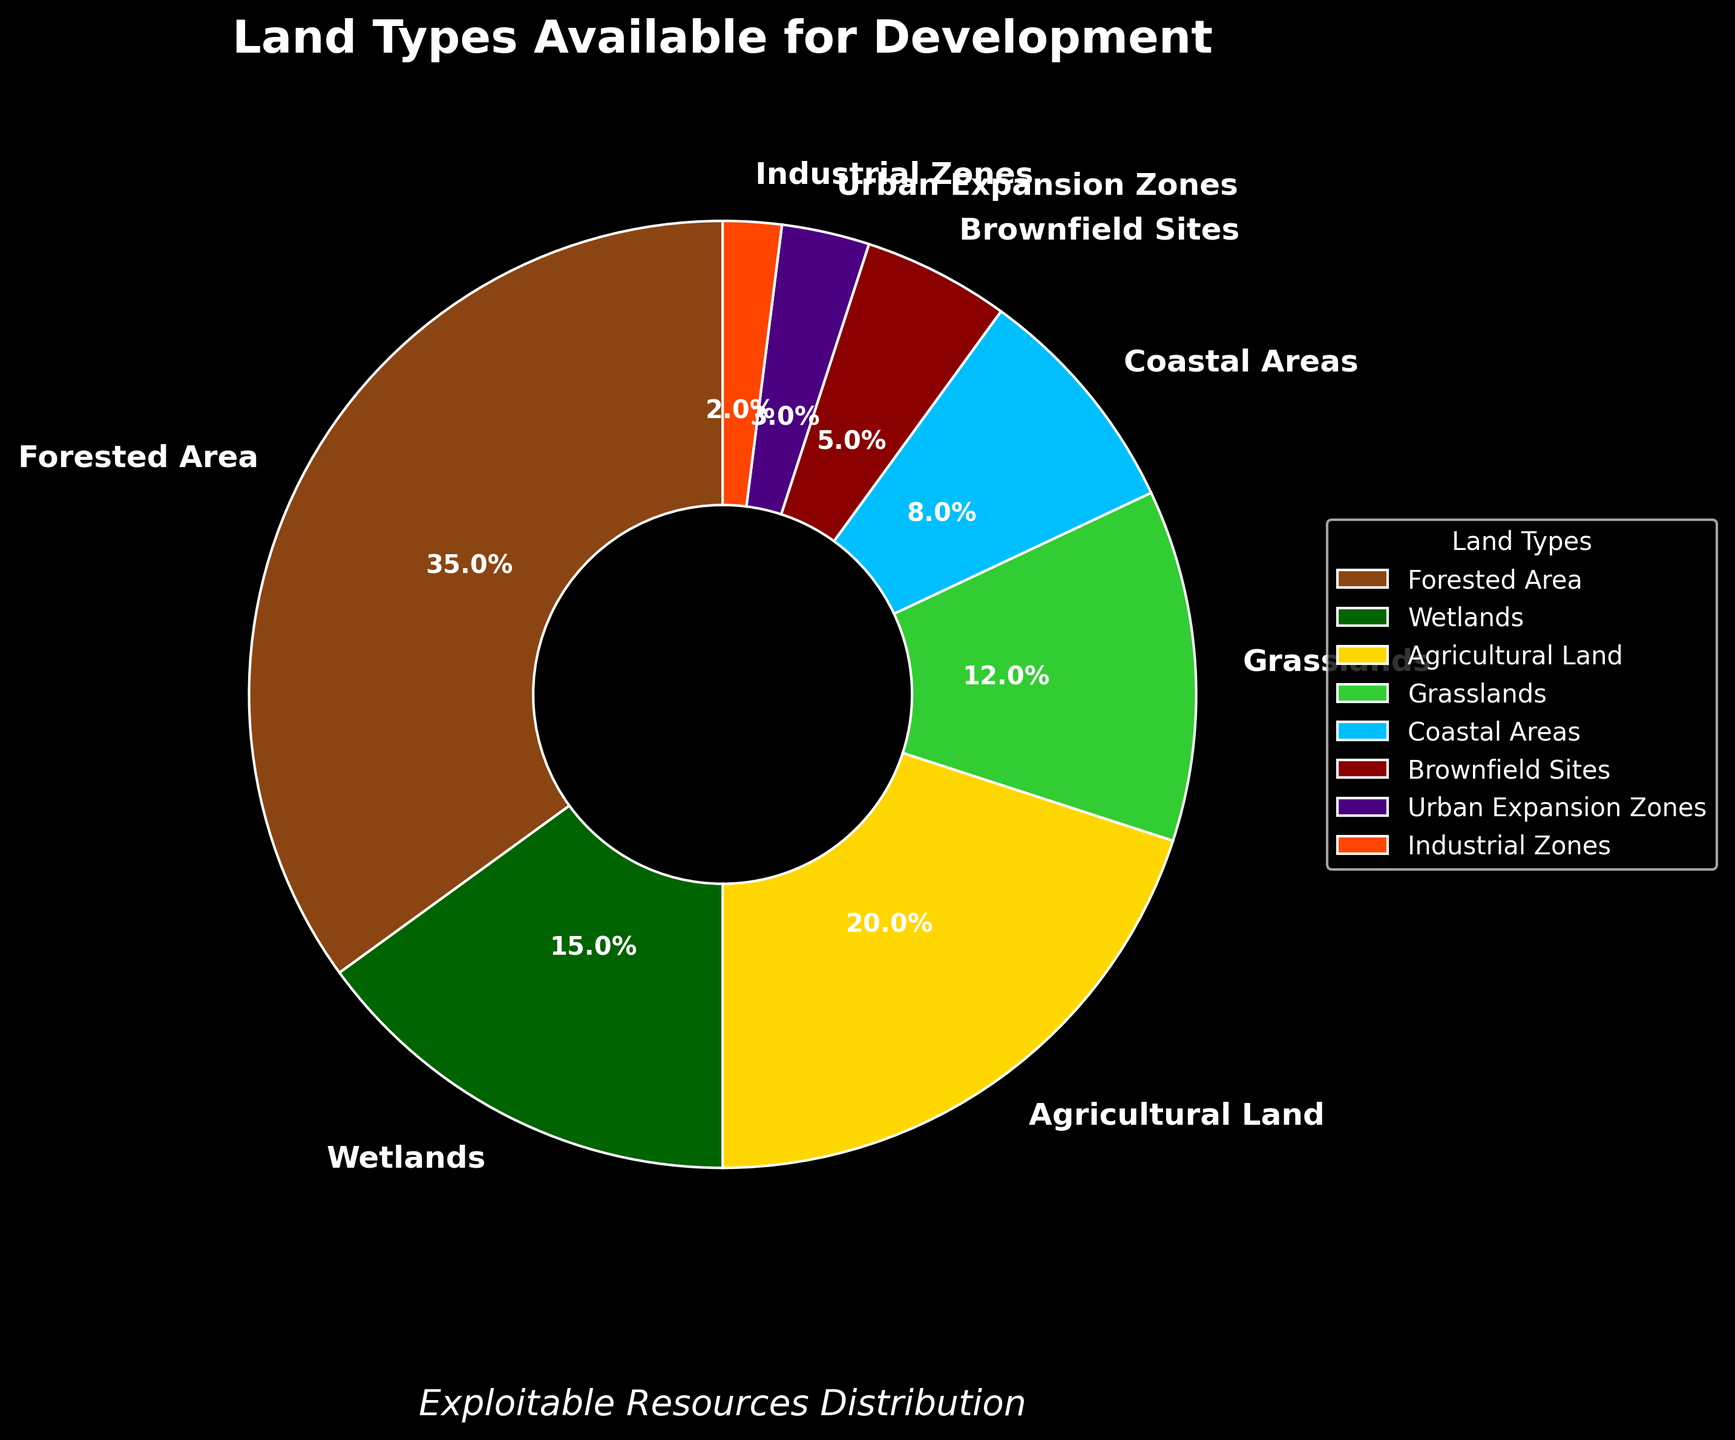What percentage of the available land types can be developed from brownfield sites and industrial zones combined? Brownfield Sites account for 5% and Industrial Zones account for 2%. Adding these together: 5% + 2% = 7%.
Answer: 7% How much more land is available in forested areas compared to urban expansion zones? Forested Areas make up 35% and Urban Expansion Zones make up 3%. Subtracting these values gives 35% - 3% = 32%.
Answer: 32% Which land type has the smallest percentage of available land for development? Examining the percentages, Industrial Zones have the smallest percentage at 2%.
Answer: Industrial Zones What fraction of the total land types does agricultural land represent, and how does it compare to the fraction of wetlands? Agricultural Land is 20% and Wetlands are 15%. The fraction for Agricultural Land is 20/100 = 1/5, and the fraction for Wetlands is 15/100 = 3/20. To compare, convert them to the same denominator: 1/5 = 4/20, which is greater than 3/20.
Answer: Agricultural Land: 1/5, Wetlands: 3/20; 1/5 > 3/20 If we combine the percentages of grasslands, coastal areas, and urban expansion zones, what is the result? Grasslands are 12%, Coastal Areas are 8%, and Urban Expansion Zones are 3%. Adding these together: 12% + 8% + 3% = 23%.
Answer: 23% How do forested areas and agricultural land percentages together compare to the total percentage of all other land types available for development? Forested Areas are 35% and Agricultural Land is 20%, adding them gives 35% + 20% = 55%. The total of all other types (100% - 55%) is 45%. Comparatively, 55% is greater than 45%.
Answer: Forested and Agricultural: 55%, Other types: 45%; 55% > 45% What is the difference in percentage between the largest and the smallest land types available for development? The largest percentage is Forested Areas at 35% and the smallest percentage is Industrial Zones at 2%. The difference is 35% - 2% = 33%.
Answer: 33% Which land types occupy more than 10% of the available land for development? Forested Areas (35%), Agricultural Land (20%), and Grasslands (12%) each have more than 10%.
Answer: Forested Areas, Agricultural Land, Grasslands What percentage of the available land for development is composed of coastal areas, and how does its visual representation appear on the chart? Coastal Areas make up 8% of the available land. Visually, it is represented by a light blue segment in the pie chart.
Answer: 8% and light blue 